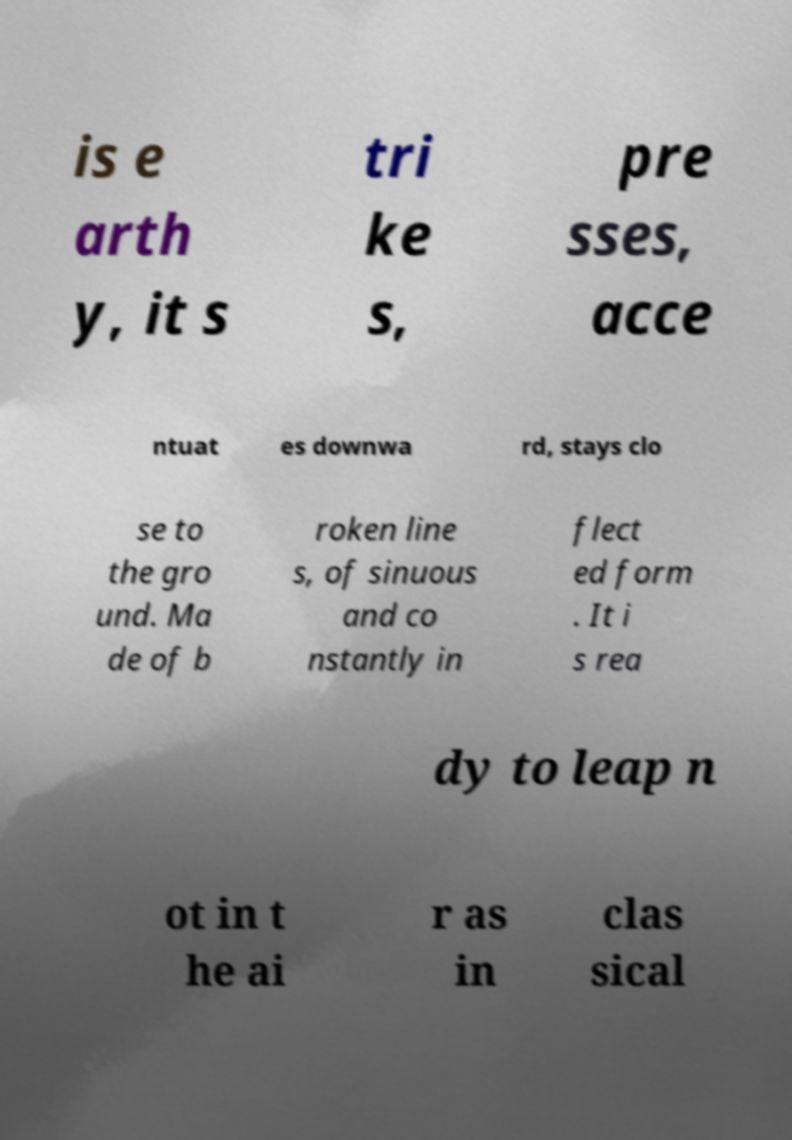Could you extract and type out the text from this image? is e arth y, it s tri ke s, pre sses, acce ntuat es downwa rd, stays clo se to the gro und. Ma de of b roken line s, of sinuous and co nstantly in flect ed form . It i s rea dy to leap n ot in t he ai r as in clas sical 